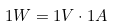Convert formula to latex. <formula><loc_0><loc_0><loc_500><loc_500>1 W = 1 V \cdot 1 A</formula> 